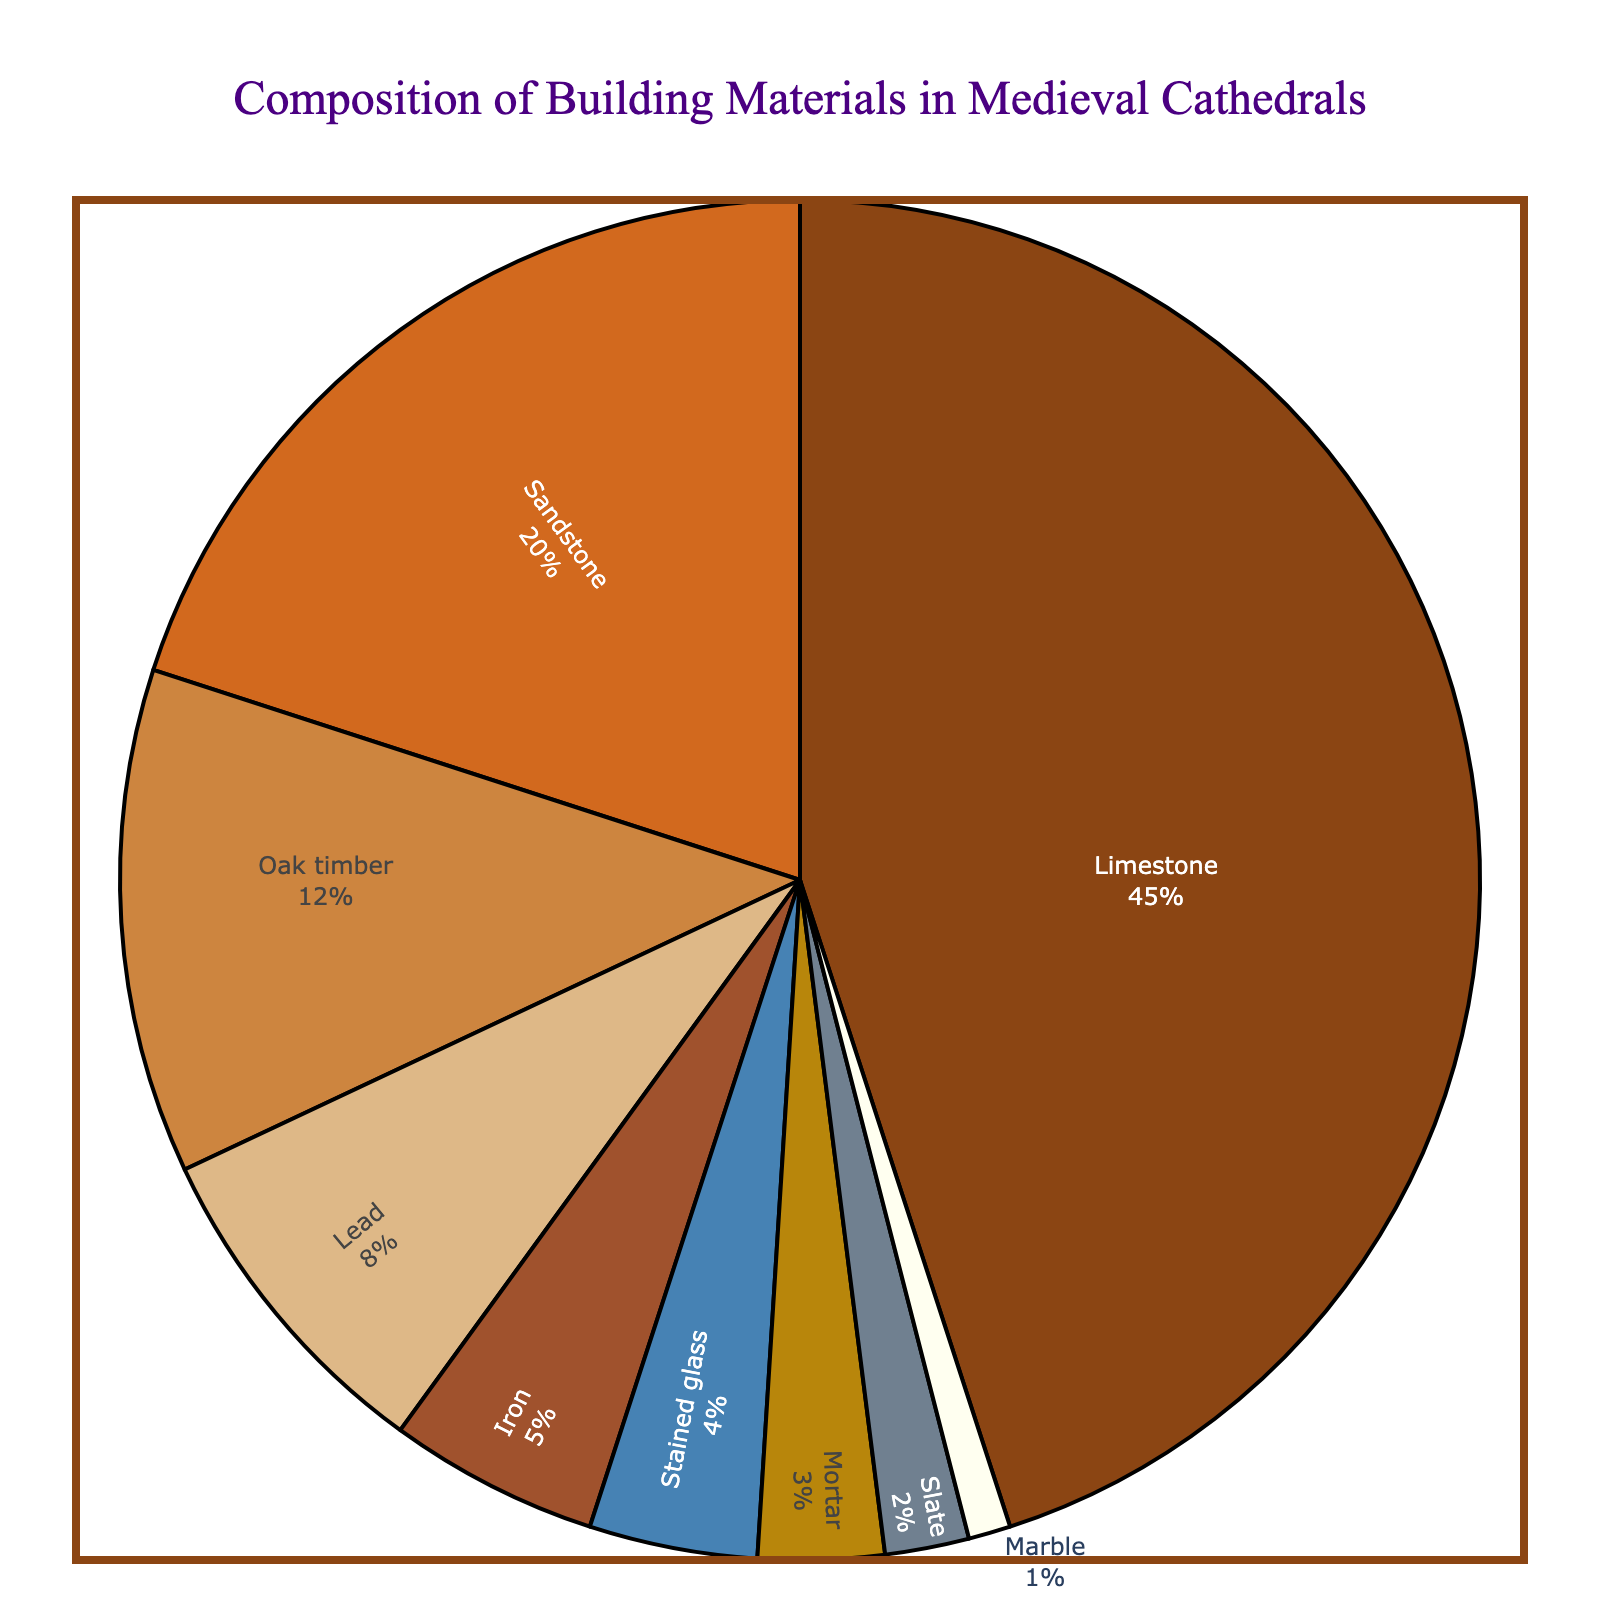What's the most used building material in medieval cathedrals? The pie chart clearly shows "Limestone" occupies the largest section of the chart. The percentage value for Limestone is the highest, at 45%.
Answer: Limestone Compare the percentage of Oak timber and Lead. Which one is higher? Oak timber is represented by a larger section of the pie chart than Lead. Oak timber is 12%, while Lead is 8%. Therefore, Oak timber is higher.
Answer: Oak timber What is the total percentage of materials used that are metals? From the chart, the materials that are metals are Lead (8%) and Iron (5%). Adding these percentages together: 8% + 5% = 13%.
Answer: 13% Which non-stone material has the smallest percentage and what is that percentage? The non-stone materials are Oak timber, Lead, Iron, Stained glass, and Mortar. Among these, Mortar has the smallest section in the pie chart, with a percentage of 3%.
Answer: Mortar, 3% What is the combined percentage of the two least used materials? The two least used materials are Marble (1%) and Slate (2%). Adding these percentages together: 1% + 2% = 3%.
Answer: 3% How does the percentage of Sandstone compare to the percentage of Limestone? The chart shows that Sandstone makes up 20% and Limestone makes up 45%. Thus, Sandstone is less than half of Limestone's percentage.
Answer: Less than half If you add the percentage of stained glass to the percentage of Oak timber, what is the total? Stained glass is 4% and Oak timber is 12%. Adding these together: 4% + 12% = 16%.
Answer: 16% Which material appears in the smallest section of the pie chart? Marble is the smallest section of the pie chart with a value of 1%.
Answer: Marble What's the difference in percentage between the most and the least used materials? The most used material is Limestone at 45%, and the least used material is Marble at 1%. The difference is 45% - 1% = 44%.
Answer: 44% What percentage of the materials is composed of stone types? The stone materials in the chart include Limestone (45%), Sandstone (20%), and Marble (1%). Summing these: 45% + 20% + 1% = 66%.
Answer: 66% 